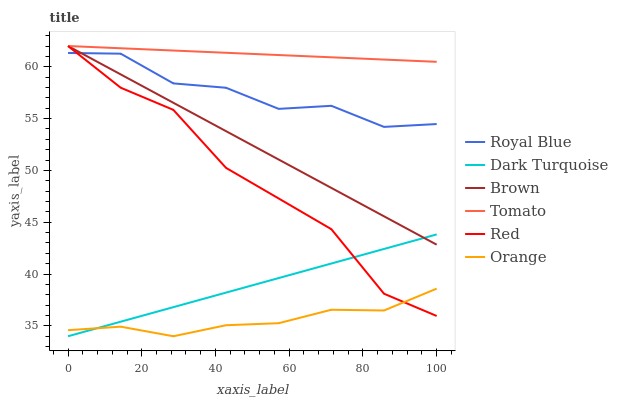Does Brown have the minimum area under the curve?
Answer yes or no. No. Does Brown have the maximum area under the curve?
Answer yes or no. No. Is Dark Turquoise the smoothest?
Answer yes or no. No. Is Dark Turquoise the roughest?
Answer yes or no. No. Does Brown have the lowest value?
Answer yes or no. No. Does Dark Turquoise have the highest value?
Answer yes or no. No. Is Orange less than Tomato?
Answer yes or no. Yes. Is Tomato greater than Orange?
Answer yes or no. Yes. Does Orange intersect Tomato?
Answer yes or no. No. 